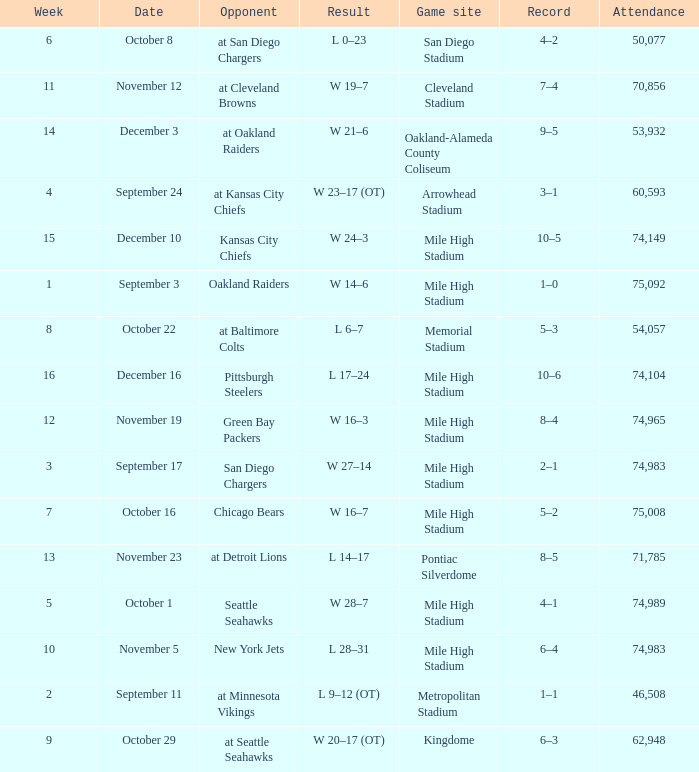Which week has a record of 5–2? 7.0. 